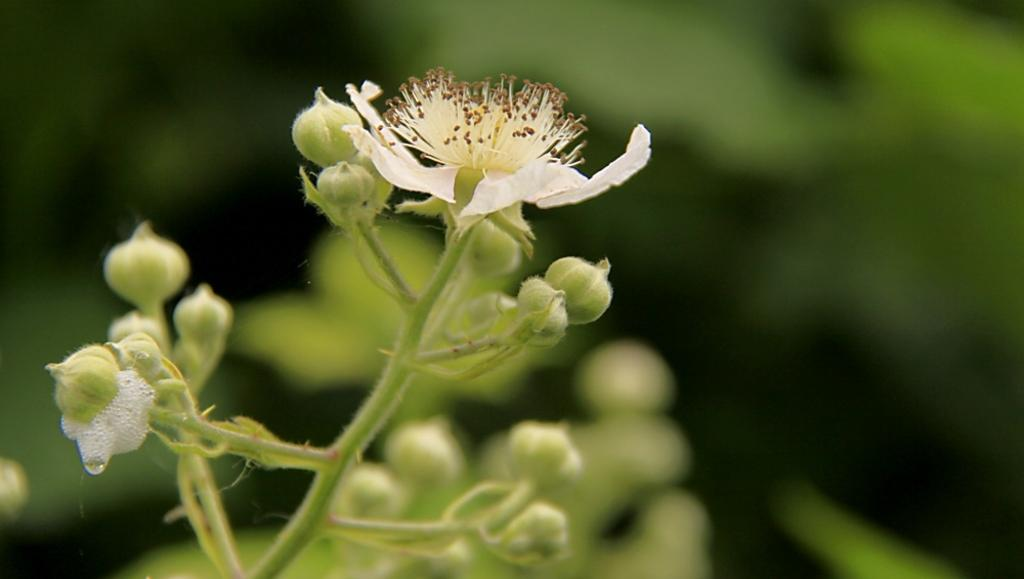What type of flower is in the image? There is a white flower in the image. Where is the flower located? The flower is on a plant. Can you describe the background of the image? The background of the image is blurry. What nation is represented by the flower in the image? The image does not represent any nation; it simply shows a white flower on a plant. Is the flower taking a bath in the image? No, the flower is not taking a bath in the image; it is on a plant. 